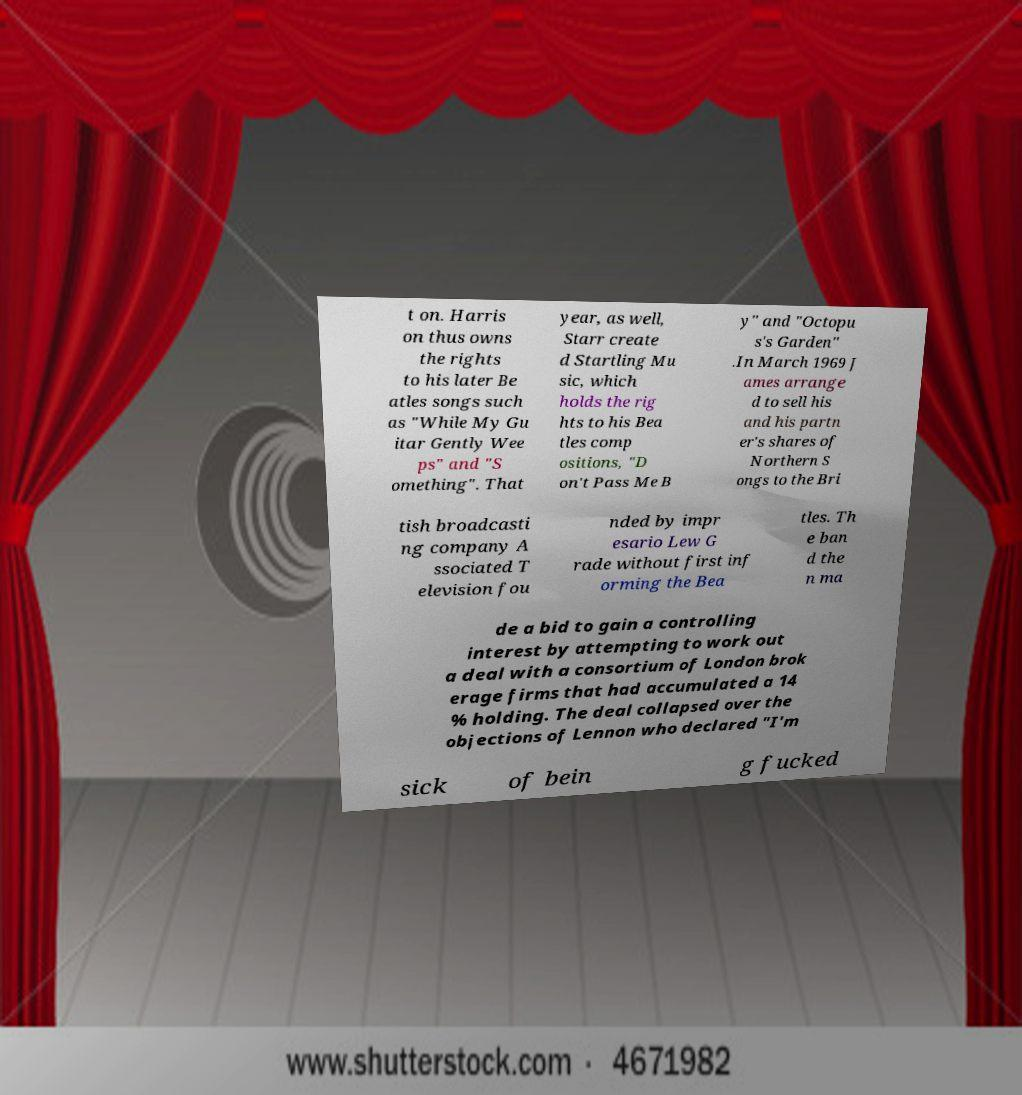I need the written content from this picture converted into text. Can you do that? t on. Harris on thus owns the rights to his later Be atles songs such as "While My Gu itar Gently Wee ps" and "S omething". That year, as well, Starr create d Startling Mu sic, which holds the rig hts to his Bea tles comp ositions, "D on't Pass Me B y" and "Octopu s's Garden" .In March 1969 J ames arrange d to sell his and his partn er's shares of Northern S ongs to the Bri tish broadcasti ng company A ssociated T elevision fou nded by impr esario Lew G rade without first inf orming the Bea tles. Th e ban d the n ma de a bid to gain a controlling interest by attempting to work out a deal with a consortium of London brok erage firms that had accumulated a 14 % holding. The deal collapsed over the objections of Lennon who declared "I'm sick of bein g fucked 